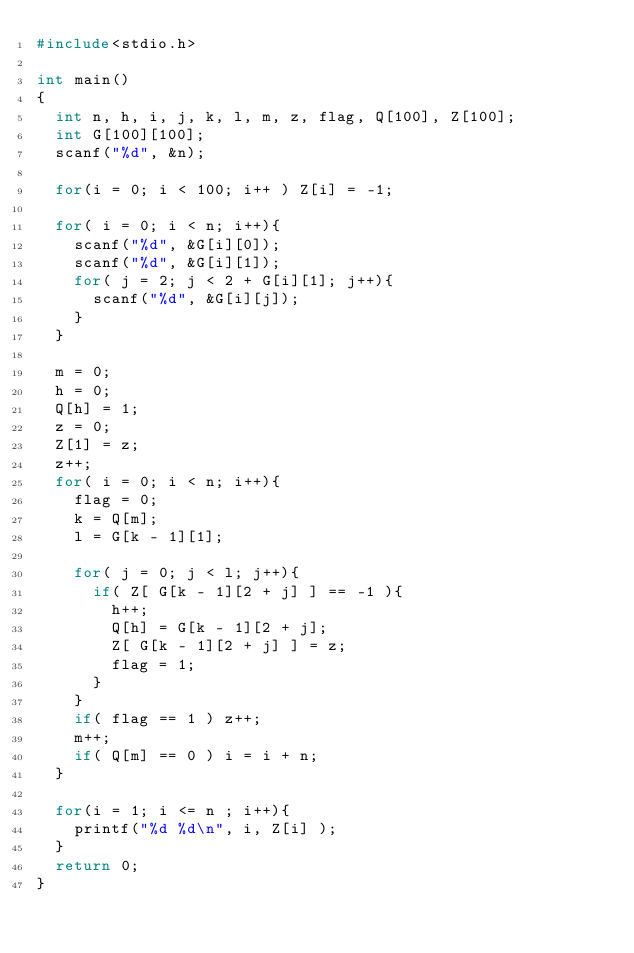<code> <loc_0><loc_0><loc_500><loc_500><_C_>#include<stdio.h>

int main()
{
  int n, h, i, j, k, l, m, z, flag, Q[100], Z[100];
  int G[100][100];
  scanf("%d", &n);
  
  for(i = 0; i < 100; i++ ) Z[i] = -1;
  
  for( i = 0; i < n; i++){
    scanf("%d", &G[i][0]);
    scanf("%d", &G[i][1]);
    for( j = 2; j < 2 + G[i][1]; j++){
      scanf("%d", &G[i][j]);
    }
  }
  
  m = 0; 
  h = 0; 
  Q[h] = 1;
  z = 0;
  Z[1] = z;
  z++;
  for( i = 0; i < n; i++){
    flag = 0;
    k = Q[m];
    l = G[k - 1][1];
    
    for( j = 0; j < l; j++){
      if( Z[ G[k - 1][2 + j] ] == -1 ){
        h++;
        Q[h] = G[k - 1][2 + j];
        Z[ G[k - 1][2 + j] ] = z;
        flag = 1;
      }
    }
    if( flag == 1 ) z++;
    m++;
    if( Q[m] == 0 ) i = i + n;
  }
  
  for(i = 1; i <= n ; i++){
    printf("%d %d\n", i, Z[i] );
  }
  return 0;
}</code> 